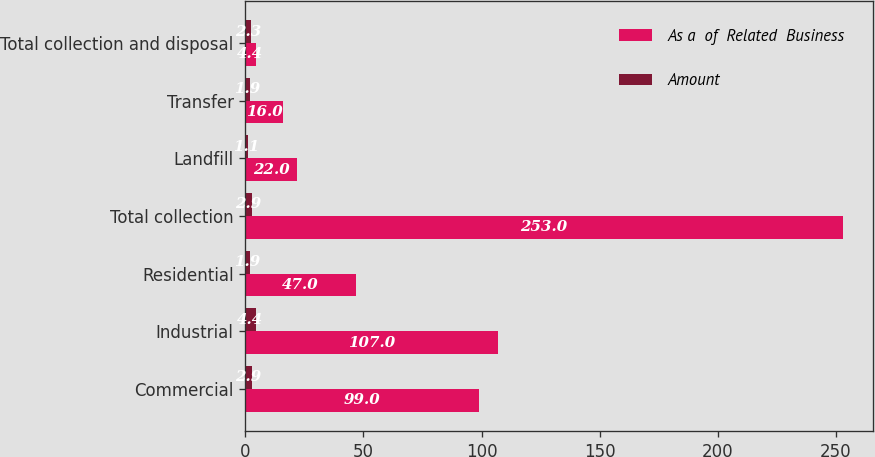Convert chart to OTSL. <chart><loc_0><loc_0><loc_500><loc_500><stacked_bar_chart><ecel><fcel>Commercial<fcel>Industrial<fcel>Residential<fcel>Total collection<fcel>Landfill<fcel>Transfer<fcel>Total collection and disposal<nl><fcel>As a  of  Related  Business<fcel>99<fcel>107<fcel>47<fcel>253<fcel>22<fcel>16<fcel>4.4<nl><fcel>Amount<fcel>2.9<fcel>4.4<fcel>1.9<fcel>2.9<fcel>1.1<fcel>1.9<fcel>2.3<nl></chart> 